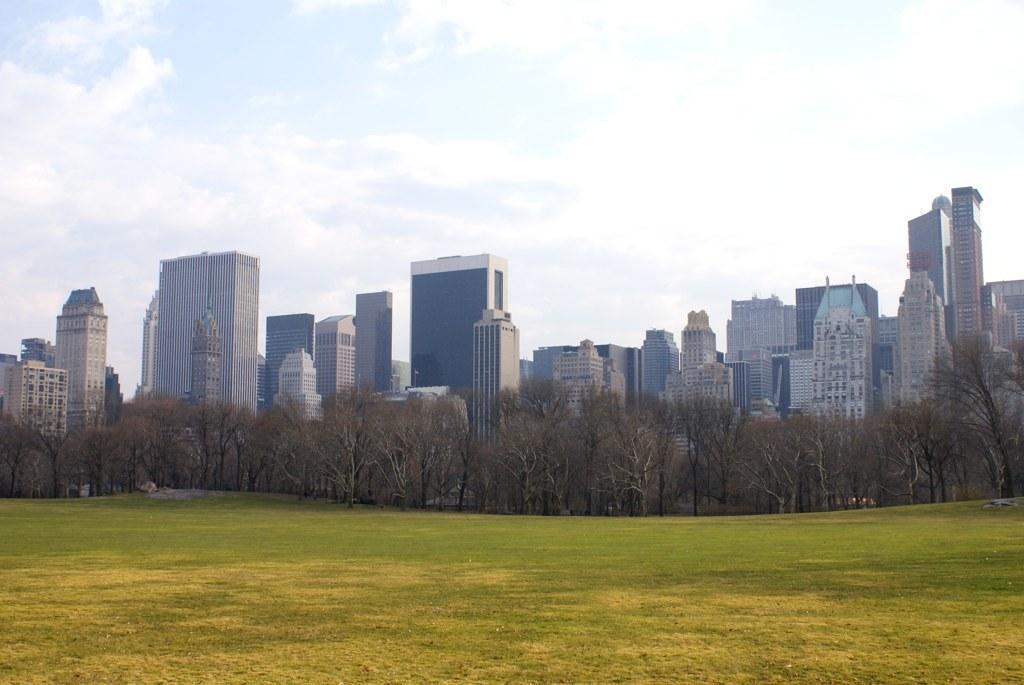Please provide a concise description of this image. In this image we can see the buildings and also trees. We can also see the sky with the clouds and at the bottom we can see the ground. 